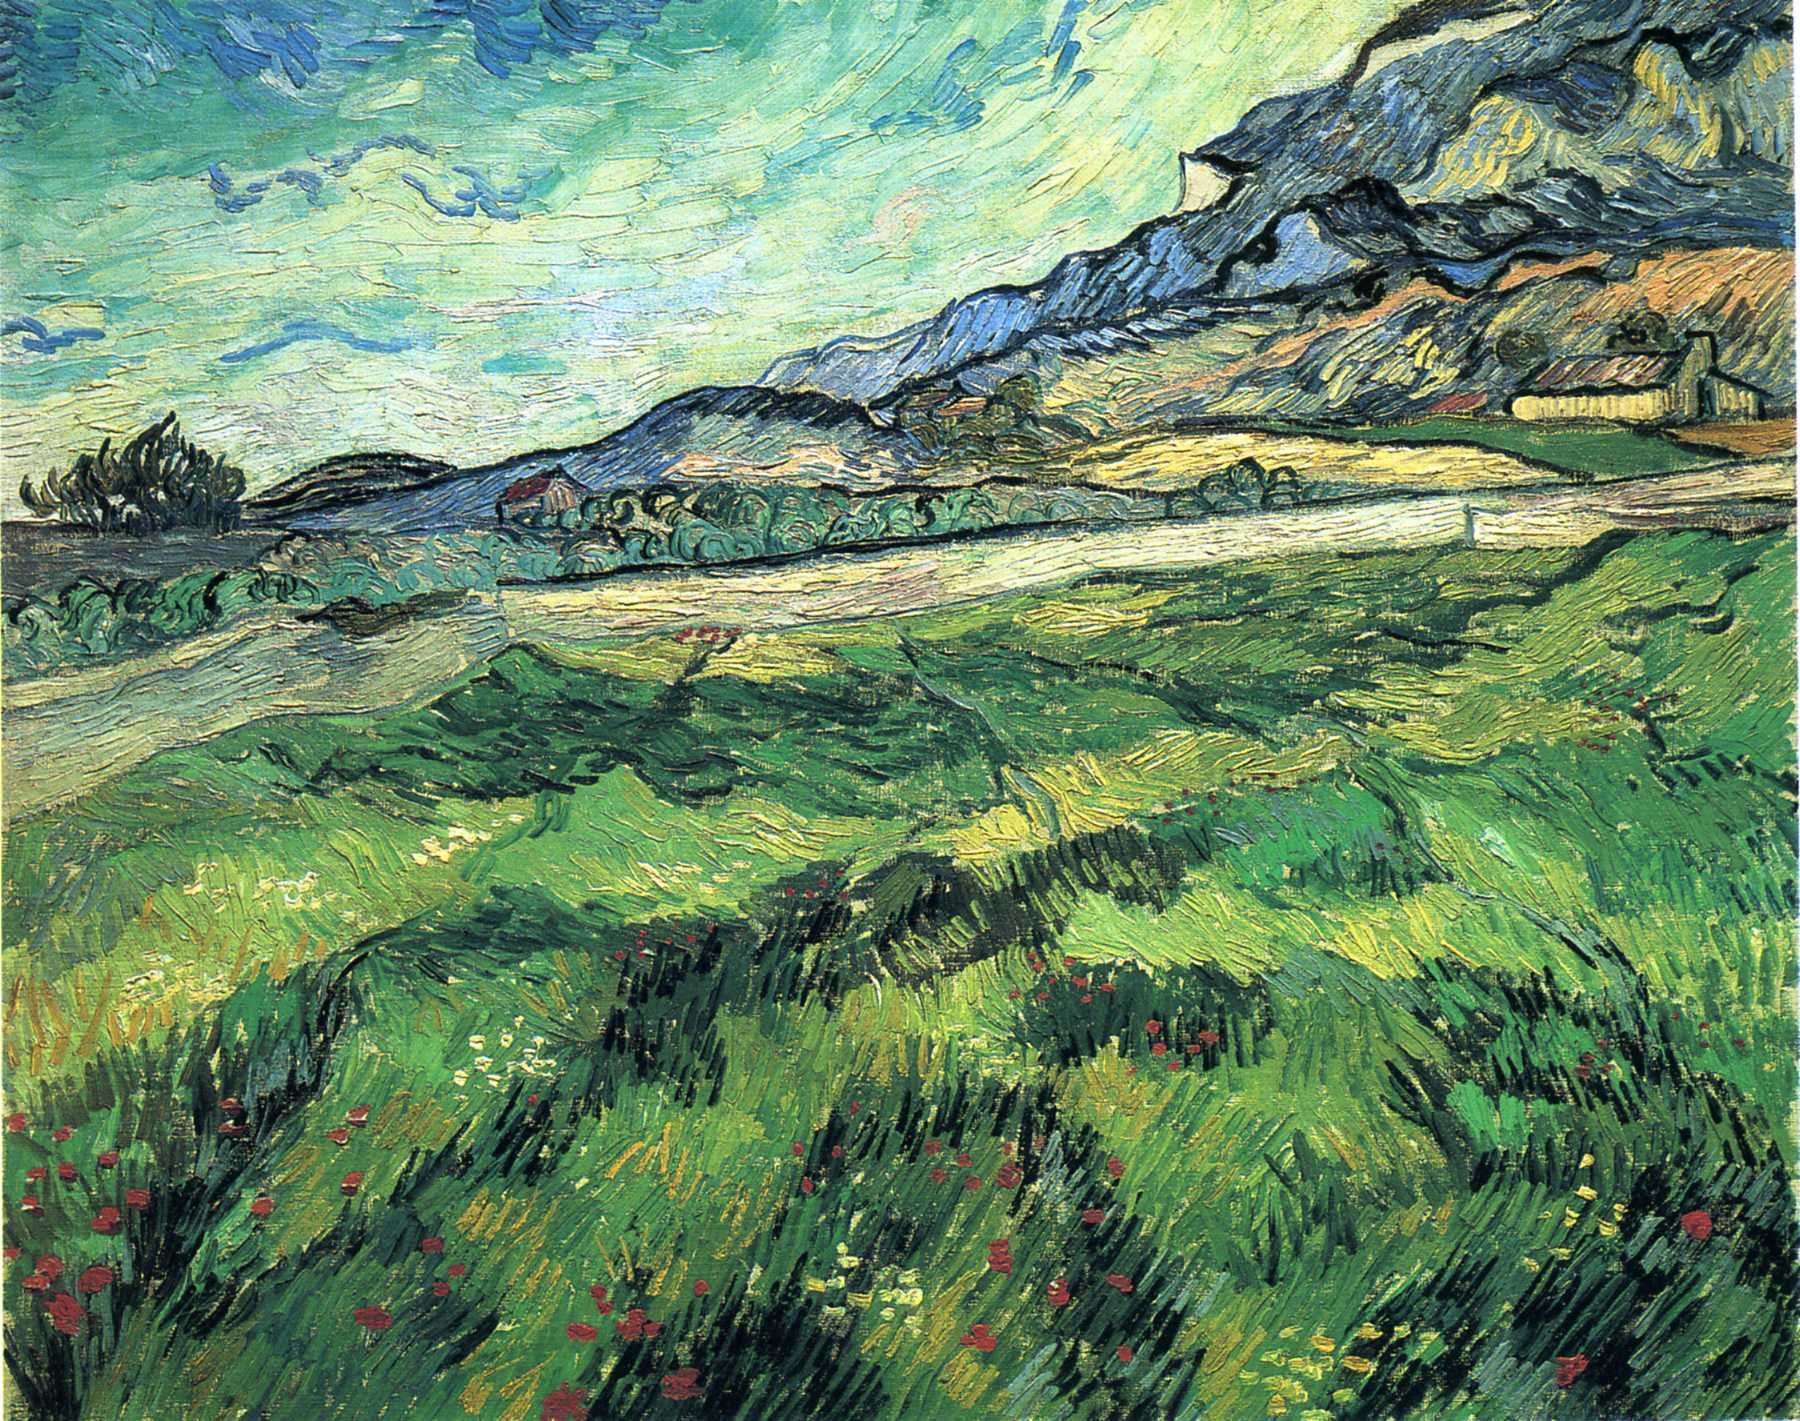Can you elaborate on the elements of the picture provided? The image is a captivating representation of a post-impressionist landscape painting by the renowned artist, Vincent Van Gogh. The painting vividly portrays a lush green field, teeming with wildflowers, set against the backdrop of a towering mountain. The sky above is depicted in a swirling blue, adding a sense of movement and dynamism to the scene. The painting is executed in Van Gogh's distinctive style, characterized by thick, visible brushstrokes and a palette of vibrant colors. This style is a hallmark of the post-impressionist genre, which emphasizes subjective emotions over objective reality. The painting, with its rich colors and expressive brushwork, is a testament to Van Gogh's mastery of this genre. 